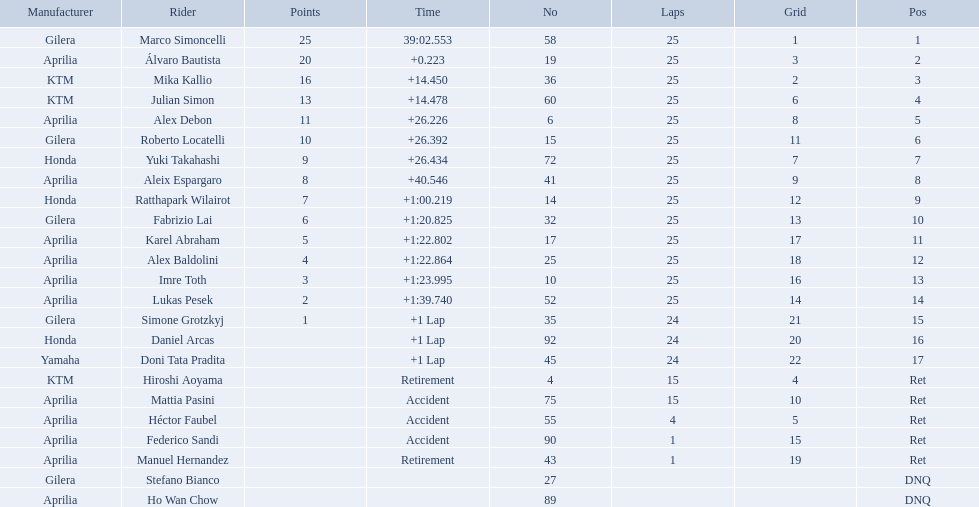How many laps did hiroshi aoyama perform? 15. How many laps did marco simoncelli perform? 25. Who performed more laps out of hiroshi aoyama and marco 
simoncelli? Marco Simoncelli. 